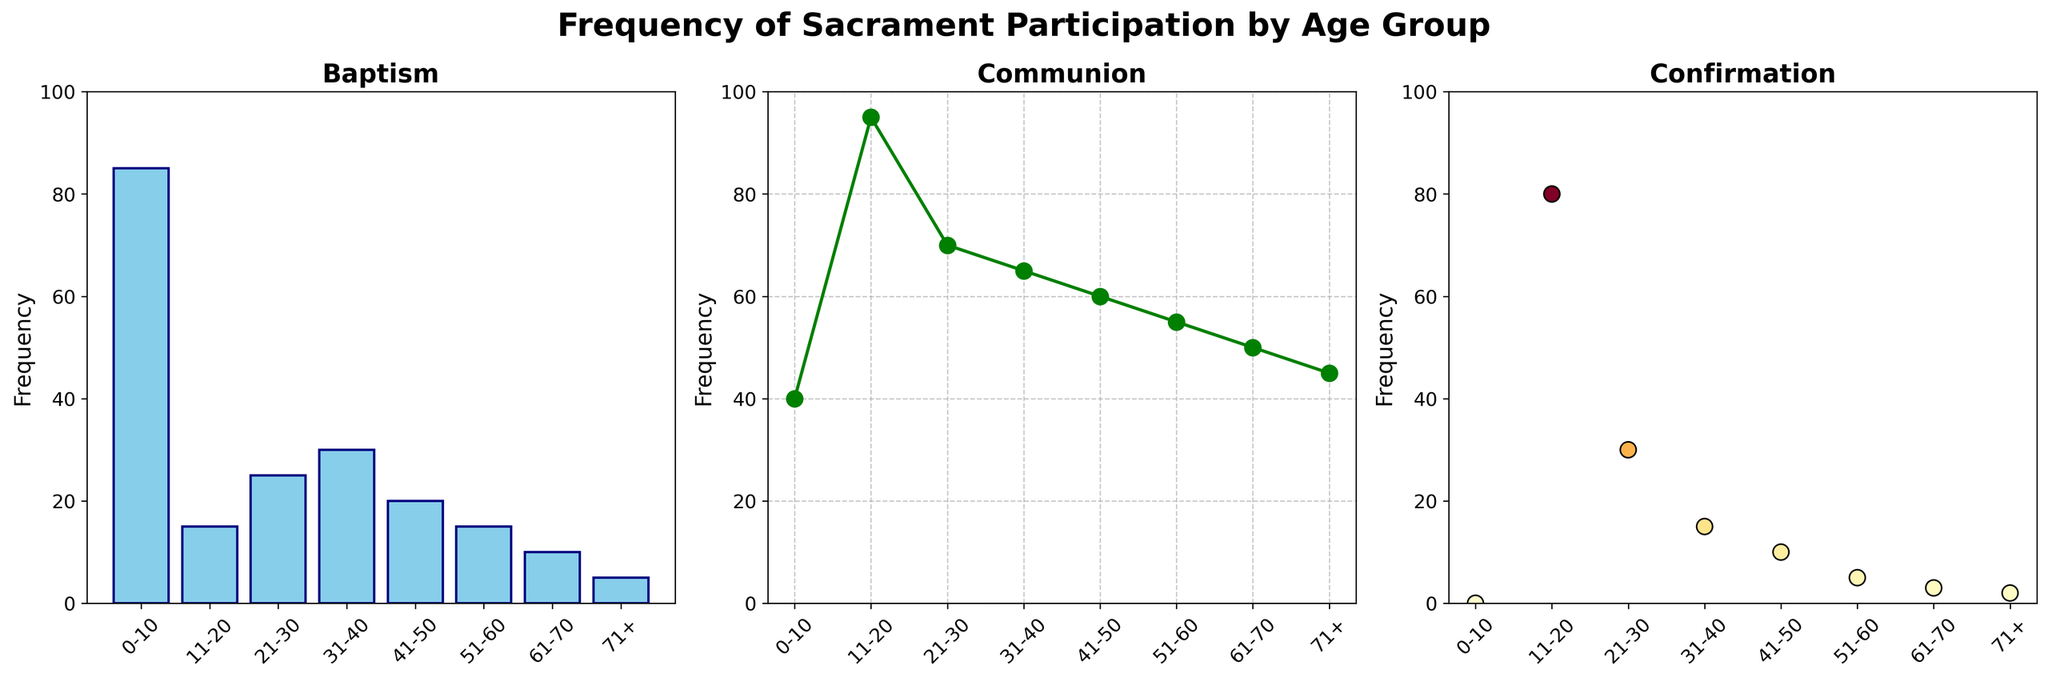What is the title of the figure? The title appears at the top of the image, centrally aligned, summarizing the content of the entire figure in a single statement.
Answer: Frequency of Sacrament Participation by Age Group How does the participation in Baptism change with age? The Baptism subplot shows a bar chart with the frequency of Baptism on the vertical axis and age groups on the horizontal axis. Observing the heights of the bars from left to right gives insight into how participation trends change with age.
Answer: It decreases Which sacrament has the highest frequency in the 11-20 age group? To find out which sacrament has the highest frequency in the 11-20 age group, compare the values for Baptism, Communion, and Confirmation at this age group. The highest value indicates the most frequent sacrament.
Answer: Communion Among the displayed sacraments, which one sees a relatively stable frequency across age groups? Look at the variation of frequencies for each sacrament type across different age groups. A relatively stable frequency means less variation between the minimum and maximum values.
Answer: Communion What is the average frequency of Confirmation across all age groups? To calculate the average frequency of Confirmation, you need to sum up the frequencies for all age groups and then divide by the number of age groups. Sum = 0 + 80 + 30 + 15 + 10 + 5 + 3 + 2 = 145, Number of age groups = 8, Average = 145/8.
Answer: 18.125 By how much does the frequency of Baptism differ between the 0-10 age group and the 11-20 age group? The frequency of Baptism in the 0-10 age group is 85 and in the 11-20 age group is 15. Subtract the frequency in the 11-20 age group from that in the 0-10 age group.
Answer: 70 How many age groups show a Confirmation frequency higher than 10? To find the number of age groups with Confirmation frequency higher than 10, count the age groups where the Confirmation value exceeds 10. The age groups with values higher than 10 are 11-20, 21-30, and 31-40.
Answer: 3 What is the relationship between age and participation in Communion based on the plot? Observe the trend line in the Communion subplot. Notice if the frequency increases, decreases, or stays constant as the age groups move from younger to older.
Answer: It slightly decreases Between the 31-40 and 41-50 age groups, which one has a higher frequency of Baptism? Compare the heights of the bars in the Baptism subplot for the 31-40 and 41-50 age groups. The taller bar indicates a higher frequency.
Answer: 31-40 What can be inferred about the relationship between age and participation in Confirmation? Examine the scatter plot for Confirmation. Observe if there is a clear trend indicating how Confirmation participation changes with increasing age. Participation is highest in the 11-20 age group and then drops significantly in older age groups.
Answer: It is highest in the 11-20 age group then decreases 